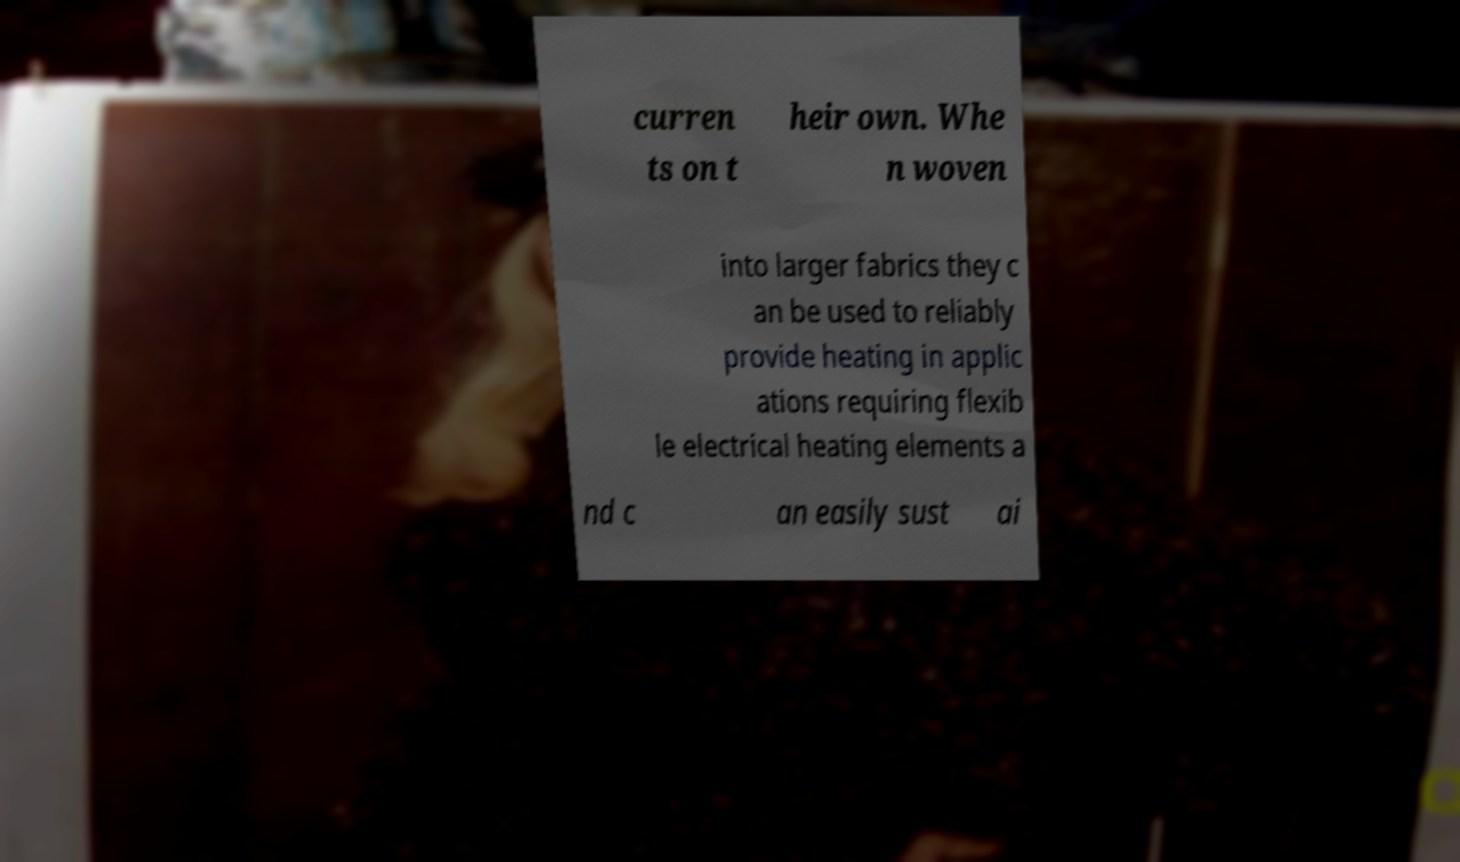Please read and relay the text visible in this image. What does it say? curren ts on t heir own. Whe n woven into larger fabrics they c an be used to reliably provide heating in applic ations requiring flexib le electrical heating elements a nd c an easily sust ai 